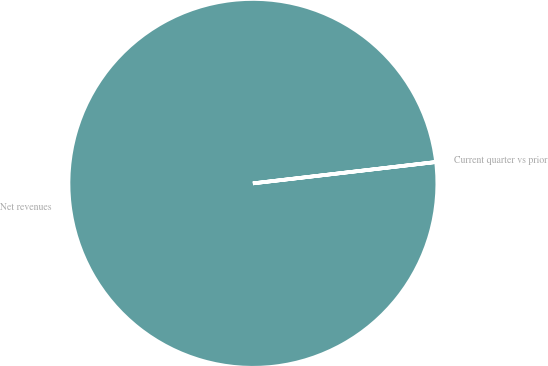Convert chart. <chart><loc_0><loc_0><loc_500><loc_500><pie_chart><fcel>Net revenues<fcel>Current quarter vs prior<nl><fcel>100.0%<fcel>0.0%<nl></chart> 